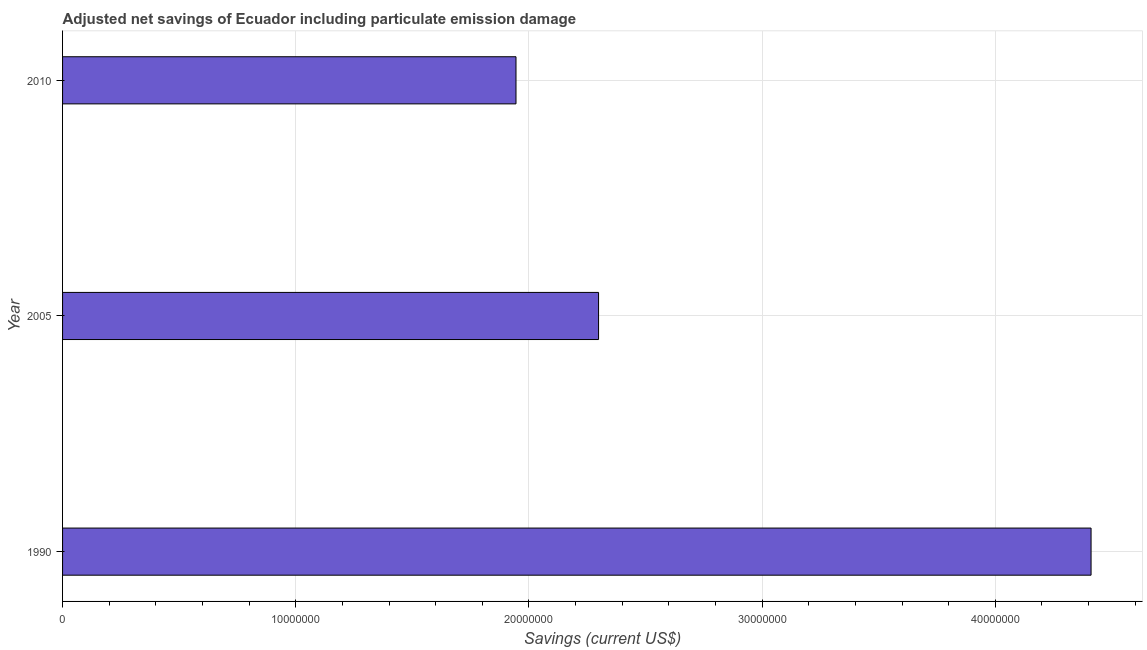Does the graph contain grids?
Give a very brief answer. Yes. What is the title of the graph?
Your answer should be very brief. Adjusted net savings of Ecuador including particulate emission damage. What is the label or title of the X-axis?
Provide a short and direct response. Savings (current US$). What is the adjusted net savings in 1990?
Keep it short and to the point. 4.41e+07. Across all years, what is the maximum adjusted net savings?
Your answer should be compact. 4.41e+07. Across all years, what is the minimum adjusted net savings?
Provide a succinct answer. 1.94e+07. In which year was the adjusted net savings minimum?
Your response must be concise. 2010. What is the sum of the adjusted net savings?
Make the answer very short. 8.65e+07. What is the difference between the adjusted net savings in 1990 and 2005?
Ensure brevity in your answer.  2.11e+07. What is the average adjusted net savings per year?
Your answer should be compact. 2.88e+07. What is the median adjusted net savings?
Offer a very short reply. 2.30e+07. In how many years, is the adjusted net savings greater than 4000000 US$?
Offer a very short reply. 3. What is the ratio of the adjusted net savings in 2005 to that in 2010?
Your answer should be compact. 1.18. Is the adjusted net savings in 2005 less than that in 2010?
Offer a very short reply. No. Is the difference between the adjusted net savings in 2005 and 2010 greater than the difference between any two years?
Make the answer very short. No. What is the difference between the highest and the second highest adjusted net savings?
Keep it short and to the point. 2.11e+07. Is the sum of the adjusted net savings in 1990 and 2005 greater than the maximum adjusted net savings across all years?
Your answer should be very brief. Yes. What is the difference between the highest and the lowest adjusted net savings?
Your response must be concise. 2.47e+07. How many bars are there?
Provide a succinct answer. 3. Are all the bars in the graph horizontal?
Provide a succinct answer. Yes. How many years are there in the graph?
Your answer should be very brief. 3. What is the difference between two consecutive major ticks on the X-axis?
Make the answer very short. 1.00e+07. What is the Savings (current US$) in 1990?
Provide a succinct answer. 4.41e+07. What is the Savings (current US$) of 2005?
Provide a succinct answer. 2.30e+07. What is the Savings (current US$) of 2010?
Offer a terse response. 1.94e+07. What is the difference between the Savings (current US$) in 1990 and 2005?
Offer a very short reply. 2.11e+07. What is the difference between the Savings (current US$) in 1990 and 2010?
Keep it short and to the point. 2.47e+07. What is the difference between the Savings (current US$) in 2005 and 2010?
Make the answer very short. 3.54e+06. What is the ratio of the Savings (current US$) in 1990 to that in 2005?
Your response must be concise. 1.92. What is the ratio of the Savings (current US$) in 1990 to that in 2010?
Your answer should be compact. 2.27. What is the ratio of the Savings (current US$) in 2005 to that in 2010?
Your answer should be very brief. 1.18. 